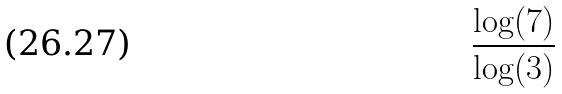<formula> <loc_0><loc_0><loc_500><loc_500>\frac { \log ( 7 ) } { \log ( 3 ) }</formula> 